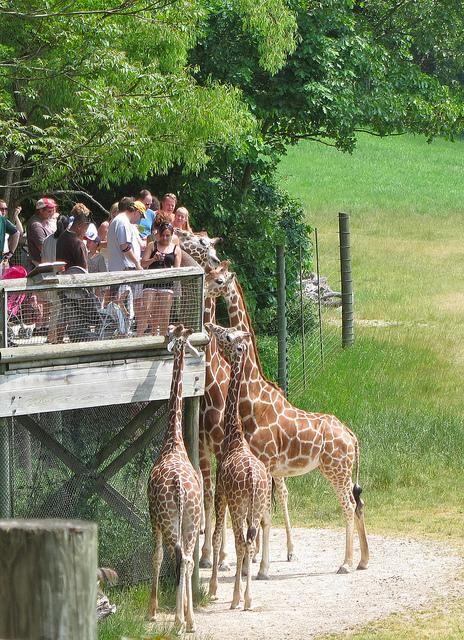Which giraffe left to right has the best chance of getting petted?

Choices:
A) second
B) very back
C) first
D) third one very back 